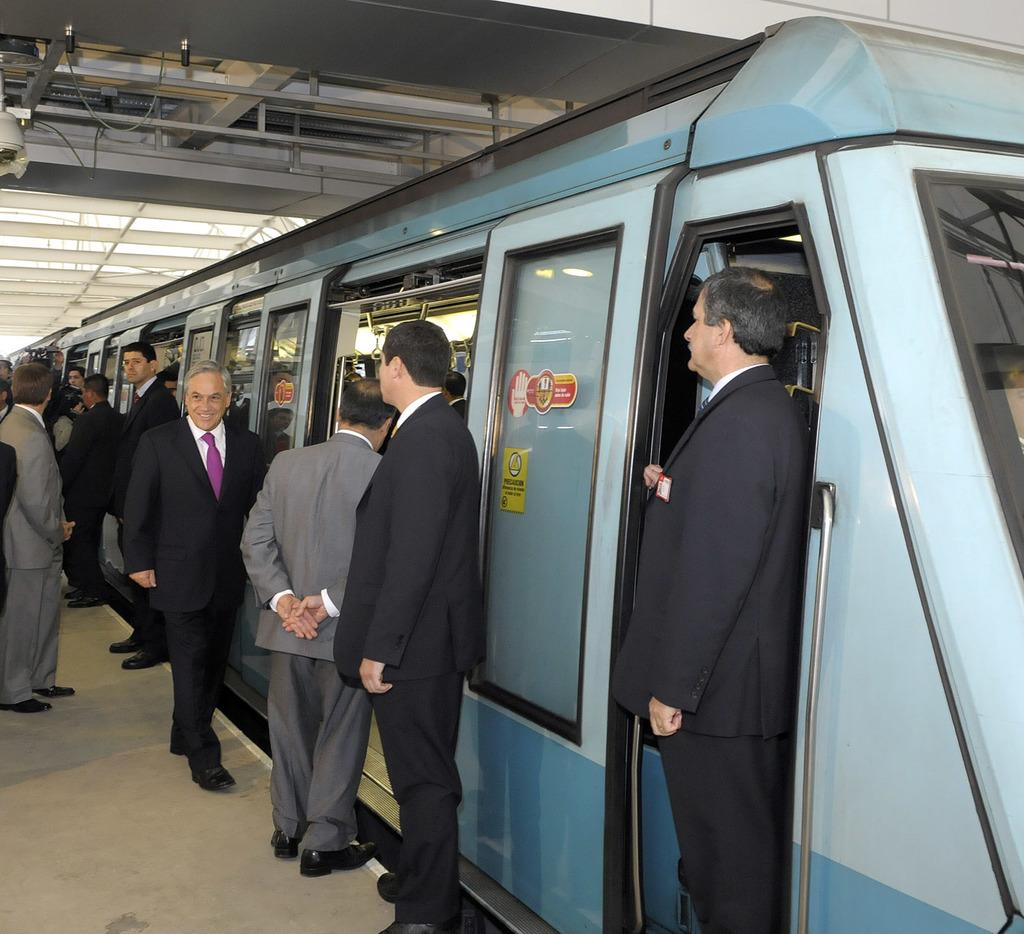What is the main subject of the image? The main subject of the image is a train. Can you describe the setting of the image? There are persons at a railway station in the image. Can you see a girl crying on the sidewalk in the image? There is no girl or sidewalk present in the image; it features a train and persons at a railway station. 